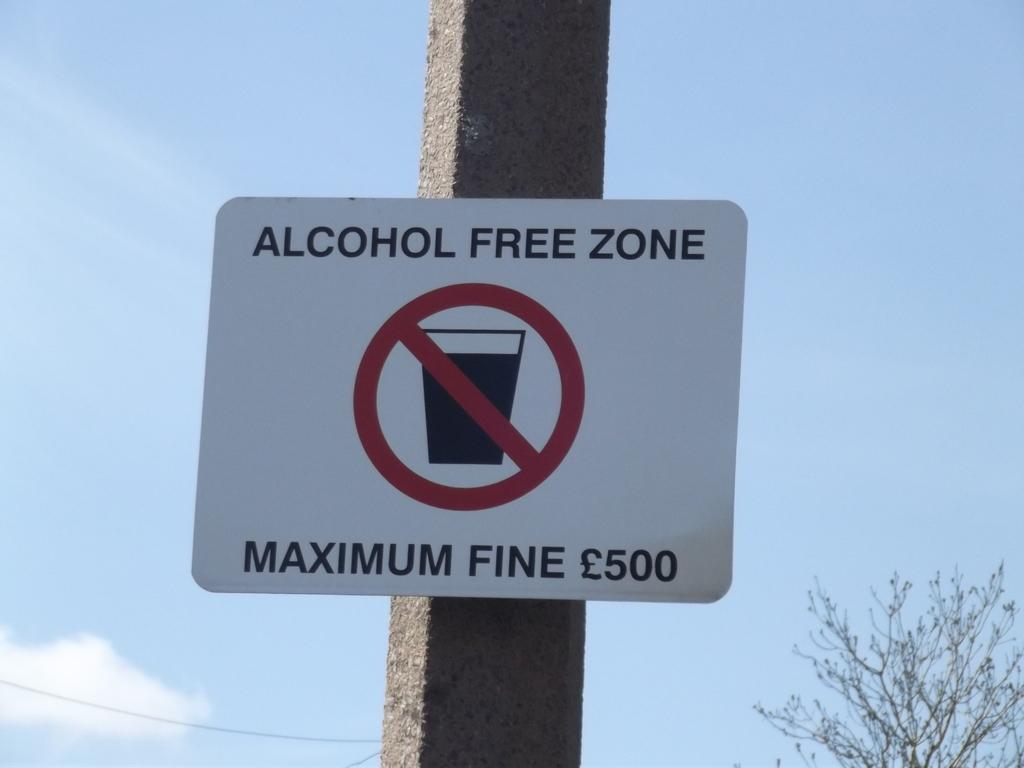<image>
Offer a succinct explanation of the picture presented. A sign designates an alcohol free zone and that there is a fine. 